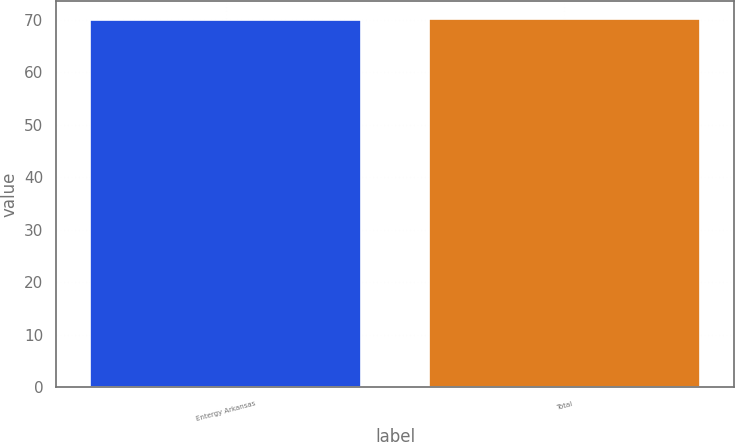Convert chart. <chart><loc_0><loc_0><loc_500><loc_500><bar_chart><fcel>Entergy Arkansas<fcel>Total<nl><fcel>70<fcel>70.1<nl></chart> 